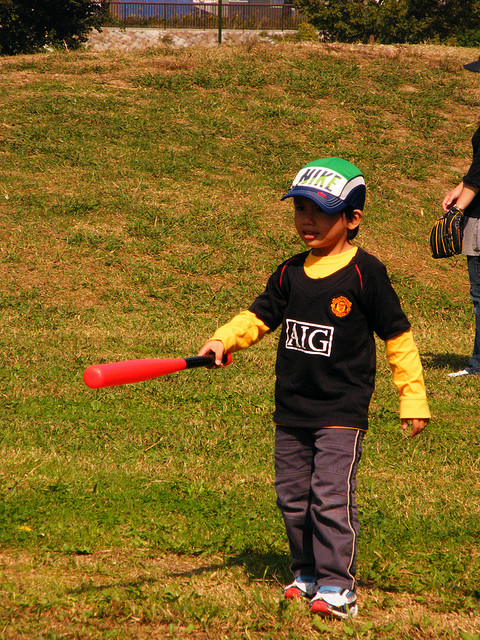Read all the text in this image. AIG NIKE 